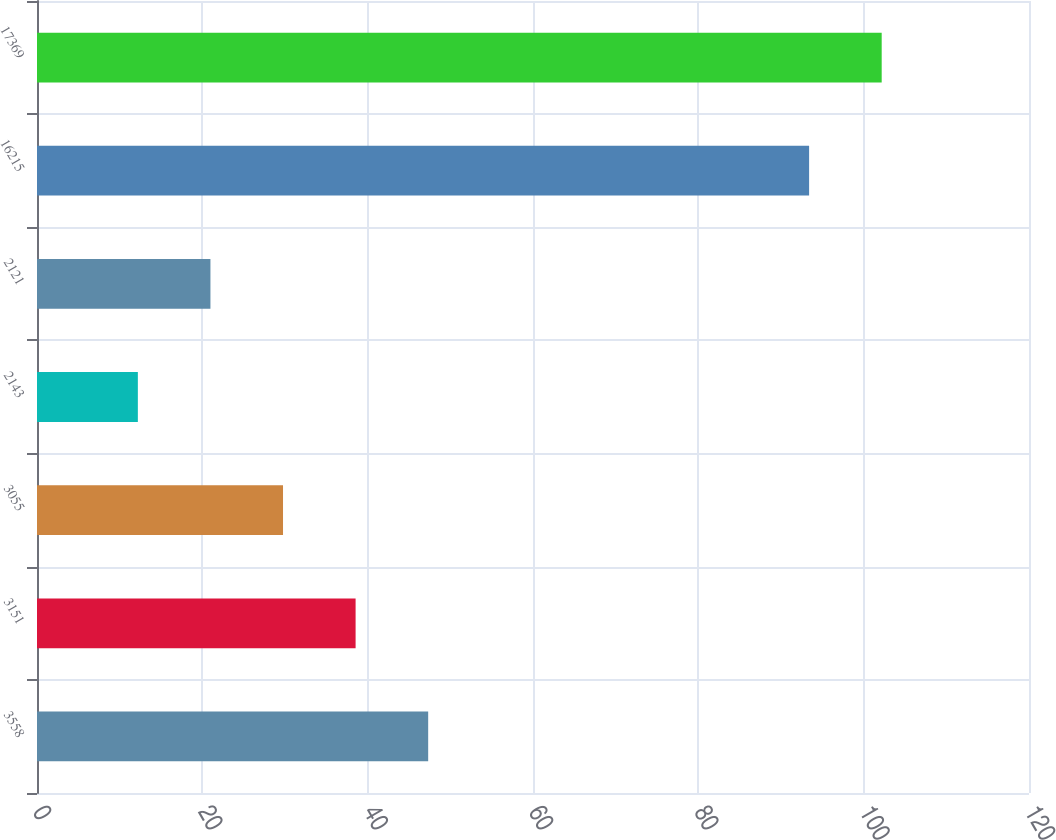<chart> <loc_0><loc_0><loc_500><loc_500><bar_chart><fcel>3558<fcel>3151<fcel>3055<fcel>2143<fcel>2121<fcel>16215<fcel>17369<nl><fcel>47.32<fcel>38.54<fcel>29.76<fcel>12.2<fcel>20.98<fcel>93.4<fcel>102.18<nl></chart> 